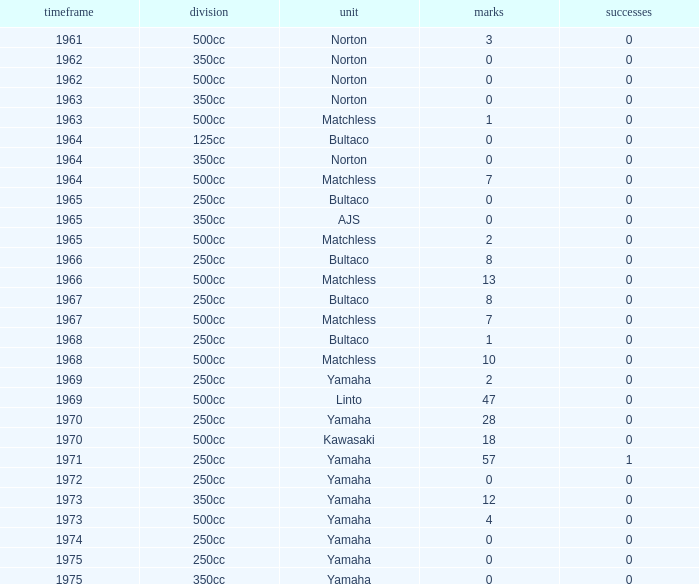What is the average wins in 250cc class for Bultaco with 8 points later than 1966? 0.0. Can you parse all the data within this table? {'header': ['timeframe', 'division', 'unit', 'marks', 'successes'], 'rows': [['1961', '500cc', 'Norton', '3', '0'], ['1962', '350cc', 'Norton', '0', '0'], ['1962', '500cc', 'Norton', '0', '0'], ['1963', '350cc', 'Norton', '0', '0'], ['1963', '500cc', 'Matchless', '1', '0'], ['1964', '125cc', 'Bultaco', '0', '0'], ['1964', '350cc', 'Norton', '0', '0'], ['1964', '500cc', 'Matchless', '7', '0'], ['1965', '250cc', 'Bultaco', '0', '0'], ['1965', '350cc', 'AJS', '0', '0'], ['1965', '500cc', 'Matchless', '2', '0'], ['1966', '250cc', 'Bultaco', '8', '0'], ['1966', '500cc', 'Matchless', '13', '0'], ['1967', '250cc', 'Bultaco', '8', '0'], ['1967', '500cc', 'Matchless', '7', '0'], ['1968', '250cc', 'Bultaco', '1', '0'], ['1968', '500cc', 'Matchless', '10', '0'], ['1969', '250cc', 'Yamaha', '2', '0'], ['1969', '500cc', 'Linto', '47', '0'], ['1970', '250cc', 'Yamaha', '28', '0'], ['1970', '500cc', 'Kawasaki', '18', '0'], ['1971', '250cc', 'Yamaha', '57', '1'], ['1972', '250cc', 'Yamaha', '0', '0'], ['1973', '350cc', 'Yamaha', '12', '0'], ['1973', '500cc', 'Yamaha', '4', '0'], ['1974', '250cc', 'Yamaha', '0', '0'], ['1975', '250cc', 'Yamaha', '0', '0'], ['1975', '350cc', 'Yamaha', '0', '0']]} 